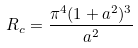<formula> <loc_0><loc_0><loc_500><loc_500>R _ { c } = \frac { \pi ^ { 4 } ( 1 + a ^ { 2 } ) ^ { 3 } } { a ^ { 2 } }</formula> 